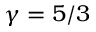Convert formula to latex. <formula><loc_0><loc_0><loc_500><loc_500>\gamma = 5 / 3</formula> 